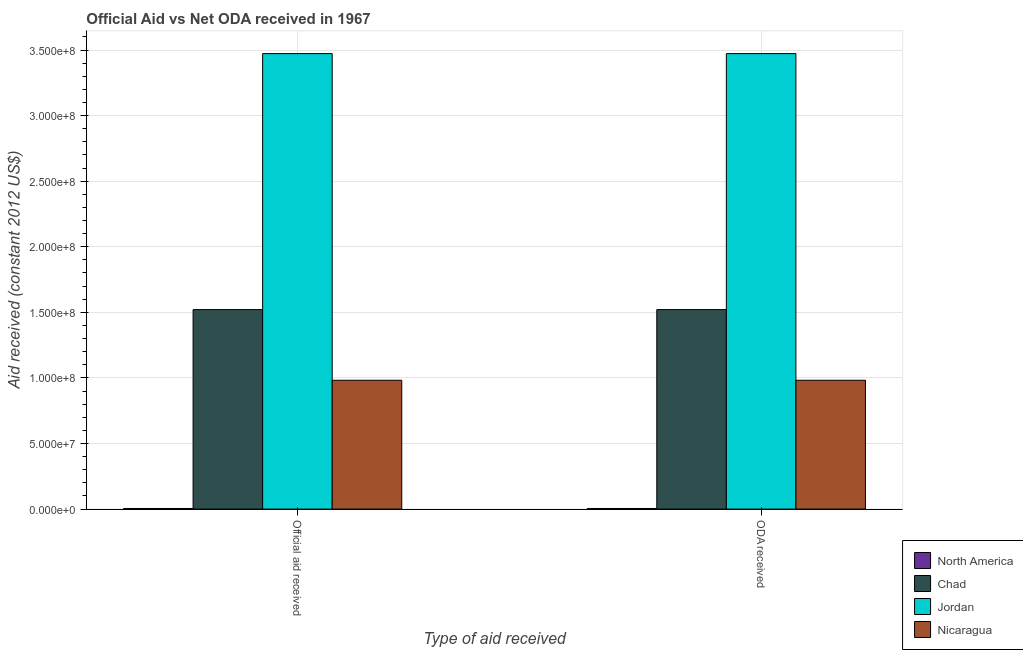How many different coloured bars are there?
Your answer should be compact. 4. How many bars are there on the 2nd tick from the left?
Provide a succinct answer. 4. How many bars are there on the 1st tick from the right?
Make the answer very short. 4. What is the label of the 2nd group of bars from the left?
Your response must be concise. ODA received. What is the official aid received in Jordan?
Your response must be concise. 3.47e+08. Across all countries, what is the maximum oda received?
Your response must be concise. 3.47e+08. Across all countries, what is the minimum official aid received?
Offer a terse response. 4.60e+05. In which country was the oda received maximum?
Offer a very short reply. Jordan. In which country was the oda received minimum?
Make the answer very short. North America. What is the total official aid received in the graph?
Make the answer very short. 5.98e+08. What is the difference between the oda received in Nicaragua and that in North America?
Your response must be concise. 9.78e+07. What is the difference between the official aid received in Jordan and the oda received in North America?
Your response must be concise. 3.47e+08. What is the average oda received per country?
Offer a very short reply. 1.50e+08. What is the ratio of the oda received in Jordan to that in North America?
Provide a succinct answer. 754.91. What does the 1st bar from the left in Official aid received represents?
Your response must be concise. North America. What does the 4th bar from the right in Official aid received represents?
Your response must be concise. North America. How many bars are there?
Ensure brevity in your answer.  8. Are all the bars in the graph horizontal?
Offer a terse response. No. How many countries are there in the graph?
Keep it short and to the point. 4. Are the values on the major ticks of Y-axis written in scientific E-notation?
Provide a succinct answer. Yes. Does the graph contain grids?
Offer a terse response. Yes. How many legend labels are there?
Keep it short and to the point. 4. What is the title of the graph?
Provide a succinct answer. Official Aid vs Net ODA received in 1967 . Does "Lower middle income" appear as one of the legend labels in the graph?
Make the answer very short. No. What is the label or title of the X-axis?
Make the answer very short. Type of aid received. What is the label or title of the Y-axis?
Provide a succinct answer. Aid received (constant 2012 US$). What is the Aid received (constant 2012 US$) in Chad in Official aid received?
Your answer should be compact. 1.52e+08. What is the Aid received (constant 2012 US$) in Jordan in Official aid received?
Offer a very short reply. 3.47e+08. What is the Aid received (constant 2012 US$) of Nicaragua in Official aid received?
Keep it short and to the point. 9.82e+07. What is the Aid received (constant 2012 US$) in Chad in ODA received?
Your answer should be very brief. 1.52e+08. What is the Aid received (constant 2012 US$) of Jordan in ODA received?
Provide a succinct answer. 3.47e+08. What is the Aid received (constant 2012 US$) in Nicaragua in ODA received?
Your answer should be very brief. 9.82e+07. Across all Type of aid received, what is the maximum Aid received (constant 2012 US$) in North America?
Provide a short and direct response. 4.60e+05. Across all Type of aid received, what is the maximum Aid received (constant 2012 US$) of Chad?
Your response must be concise. 1.52e+08. Across all Type of aid received, what is the maximum Aid received (constant 2012 US$) in Jordan?
Provide a succinct answer. 3.47e+08. Across all Type of aid received, what is the maximum Aid received (constant 2012 US$) in Nicaragua?
Provide a short and direct response. 9.82e+07. Across all Type of aid received, what is the minimum Aid received (constant 2012 US$) of North America?
Your answer should be compact. 4.60e+05. Across all Type of aid received, what is the minimum Aid received (constant 2012 US$) of Chad?
Offer a terse response. 1.52e+08. Across all Type of aid received, what is the minimum Aid received (constant 2012 US$) of Jordan?
Your answer should be very brief. 3.47e+08. Across all Type of aid received, what is the minimum Aid received (constant 2012 US$) of Nicaragua?
Your response must be concise. 9.82e+07. What is the total Aid received (constant 2012 US$) of North America in the graph?
Your response must be concise. 9.20e+05. What is the total Aid received (constant 2012 US$) of Chad in the graph?
Make the answer very short. 3.04e+08. What is the total Aid received (constant 2012 US$) in Jordan in the graph?
Give a very brief answer. 6.95e+08. What is the total Aid received (constant 2012 US$) of Nicaragua in the graph?
Give a very brief answer. 1.96e+08. What is the difference between the Aid received (constant 2012 US$) of Chad in Official aid received and that in ODA received?
Ensure brevity in your answer.  0. What is the difference between the Aid received (constant 2012 US$) of North America in Official aid received and the Aid received (constant 2012 US$) of Chad in ODA received?
Offer a very short reply. -1.52e+08. What is the difference between the Aid received (constant 2012 US$) of North America in Official aid received and the Aid received (constant 2012 US$) of Jordan in ODA received?
Your response must be concise. -3.47e+08. What is the difference between the Aid received (constant 2012 US$) in North America in Official aid received and the Aid received (constant 2012 US$) in Nicaragua in ODA received?
Offer a very short reply. -9.78e+07. What is the difference between the Aid received (constant 2012 US$) of Chad in Official aid received and the Aid received (constant 2012 US$) of Jordan in ODA received?
Your response must be concise. -1.95e+08. What is the difference between the Aid received (constant 2012 US$) in Chad in Official aid received and the Aid received (constant 2012 US$) in Nicaragua in ODA received?
Provide a succinct answer. 5.39e+07. What is the difference between the Aid received (constant 2012 US$) of Jordan in Official aid received and the Aid received (constant 2012 US$) of Nicaragua in ODA received?
Your answer should be very brief. 2.49e+08. What is the average Aid received (constant 2012 US$) of Chad per Type of aid received?
Your answer should be compact. 1.52e+08. What is the average Aid received (constant 2012 US$) of Jordan per Type of aid received?
Make the answer very short. 3.47e+08. What is the average Aid received (constant 2012 US$) in Nicaragua per Type of aid received?
Give a very brief answer. 9.82e+07. What is the difference between the Aid received (constant 2012 US$) in North America and Aid received (constant 2012 US$) in Chad in Official aid received?
Ensure brevity in your answer.  -1.52e+08. What is the difference between the Aid received (constant 2012 US$) of North America and Aid received (constant 2012 US$) of Jordan in Official aid received?
Offer a very short reply. -3.47e+08. What is the difference between the Aid received (constant 2012 US$) of North America and Aid received (constant 2012 US$) of Nicaragua in Official aid received?
Offer a very short reply. -9.78e+07. What is the difference between the Aid received (constant 2012 US$) in Chad and Aid received (constant 2012 US$) in Jordan in Official aid received?
Ensure brevity in your answer.  -1.95e+08. What is the difference between the Aid received (constant 2012 US$) in Chad and Aid received (constant 2012 US$) in Nicaragua in Official aid received?
Provide a succinct answer. 5.39e+07. What is the difference between the Aid received (constant 2012 US$) of Jordan and Aid received (constant 2012 US$) of Nicaragua in Official aid received?
Your answer should be very brief. 2.49e+08. What is the difference between the Aid received (constant 2012 US$) of North America and Aid received (constant 2012 US$) of Chad in ODA received?
Your answer should be very brief. -1.52e+08. What is the difference between the Aid received (constant 2012 US$) of North America and Aid received (constant 2012 US$) of Jordan in ODA received?
Offer a terse response. -3.47e+08. What is the difference between the Aid received (constant 2012 US$) in North America and Aid received (constant 2012 US$) in Nicaragua in ODA received?
Keep it short and to the point. -9.78e+07. What is the difference between the Aid received (constant 2012 US$) in Chad and Aid received (constant 2012 US$) in Jordan in ODA received?
Ensure brevity in your answer.  -1.95e+08. What is the difference between the Aid received (constant 2012 US$) of Chad and Aid received (constant 2012 US$) of Nicaragua in ODA received?
Offer a very short reply. 5.39e+07. What is the difference between the Aid received (constant 2012 US$) in Jordan and Aid received (constant 2012 US$) in Nicaragua in ODA received?
Ensure brevity in your answer.  2.49e+08. What is the ratio of the Aid received (constant 2012 US$) in North America in Official aid received to that in ODA received?
Offer a terse response. 1. What is the ratio of the Aid received (constant 2012 US$) of Jordan in Official aid received to that in ODA received?
Give a very brief answer. 1. What is the ratio of the Aid received (constant 2012 US$) in Nicaragua in Official aid received to that in ODA received?
Your response must be concise. 1. What is the difference between the highest and the second highest Aid received (constant 2012 US$) in North America?
Keep it short and to the point. 0. What is the difference between the highest and the lowest Aid received (constant 2012 US$) of Jordan?
Make the answer very short. 0. What is the difference between the highest and the lowest Aid received (constant 2012 US$) in Nicaragua?
Make the answer very short. 0. 